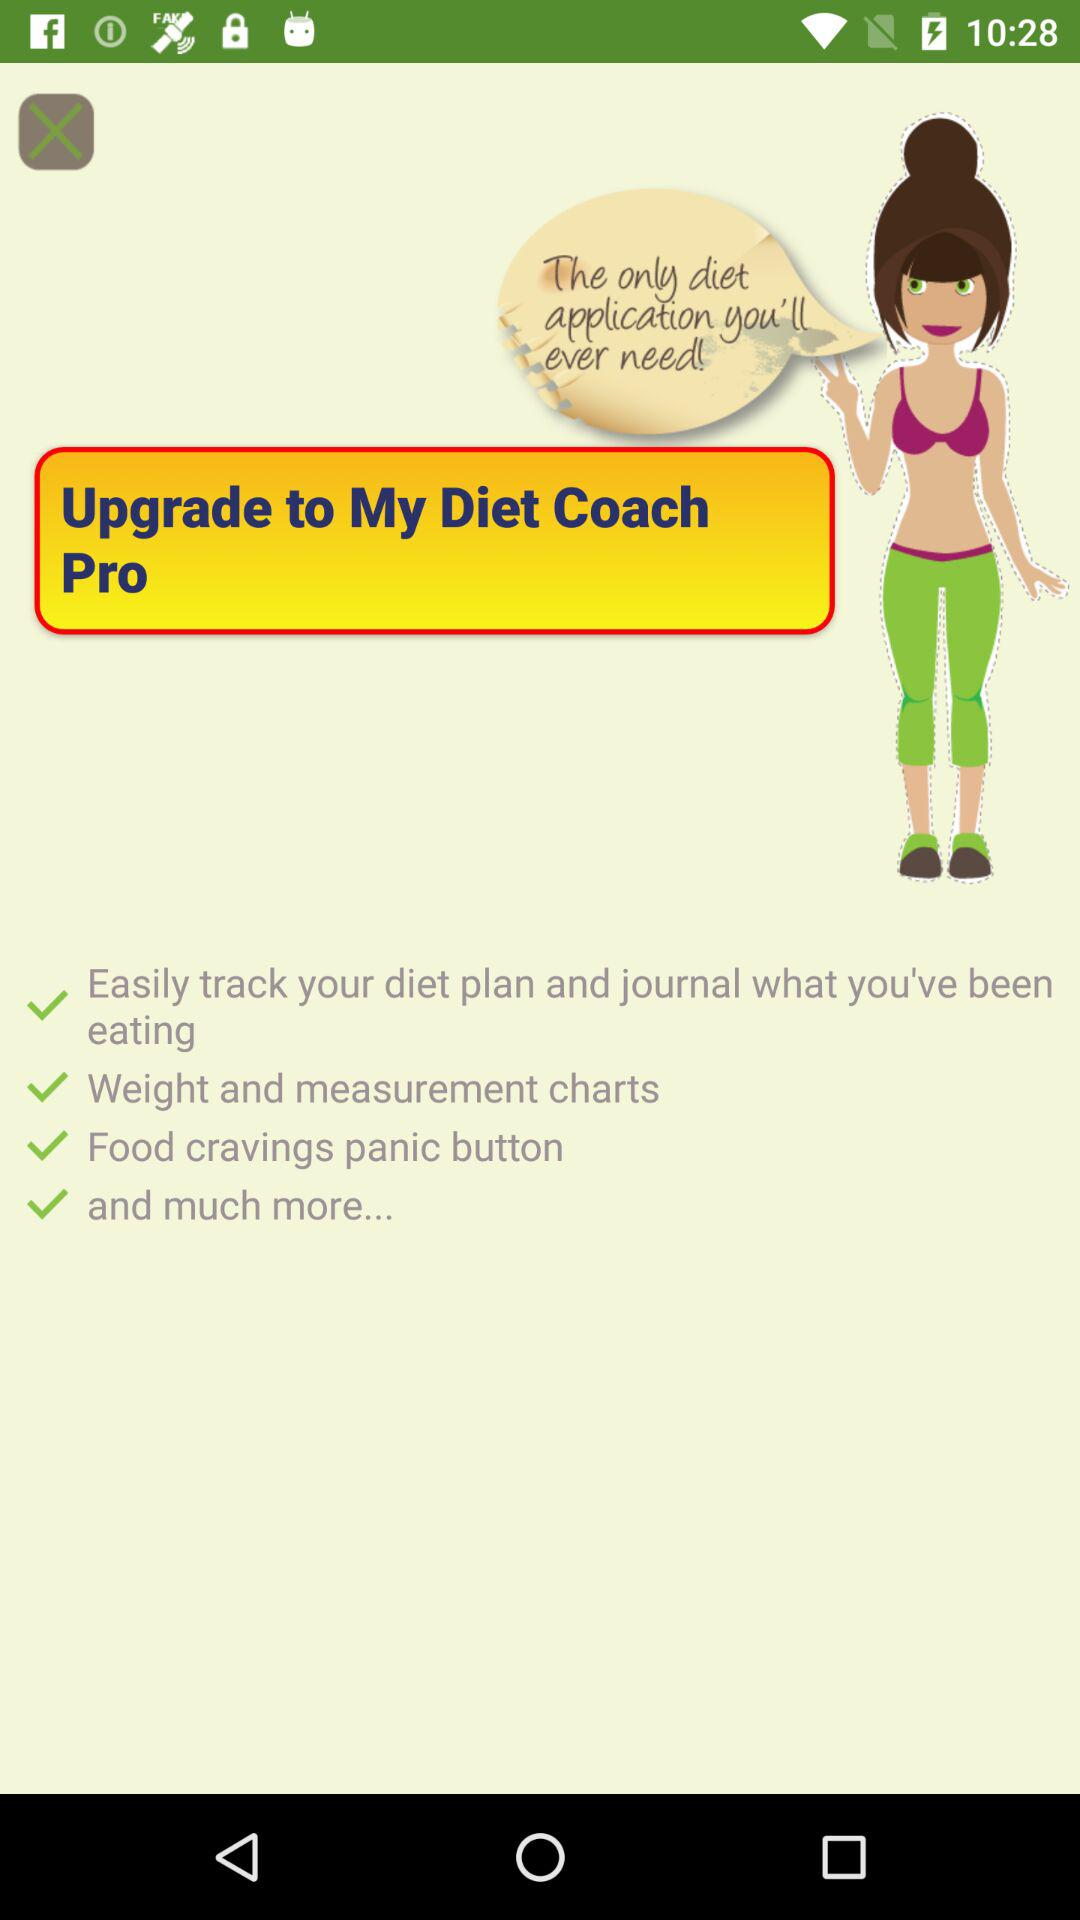What is the name of the application? The name of the application is "My Diet Coach". 